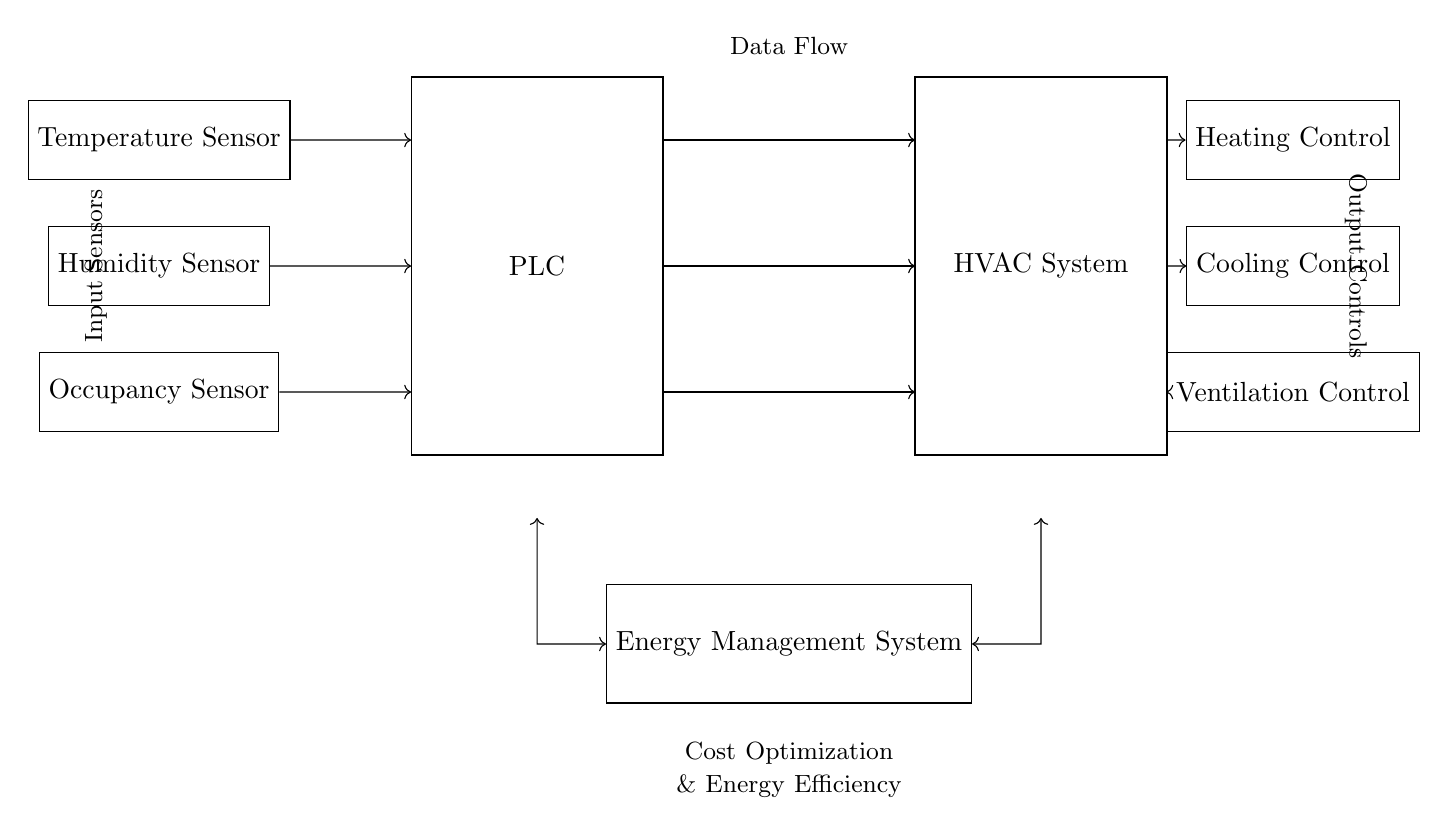What are the types of sensors in the circuit? The circuit features three types of sensors: temperature, humidity, and occupancy sensors. Each sensor is represented in the diagram, indicating their specific role in monitoring environmental conditions.
Answer: Temperature, humidity, occupancy What component manages the energy efficiency? The Energy Management System (EMS) is responsible for optimizing costs and energy efficiency in the circuit. It is represented by a rectangle labeled "Energy Management System."
Answer: Energy Management System How many output control components are there? There are three output control components: heating control, cooling control, and ventilation control. Each is clearly marked in the diagram, indicating their function in the HVAC system.
Answer: Three Which sensors send data to the PLC? The sensors that send data to the PLC are the temperature sensor, humidity sensor, and occupancy sensor. These sensors are connected by arrows pointing towards the PLC, indicating the data flow direction.
Answer: Temperature sensor, humidity sensor, occupancy sensor What is the main purpose of the PLC in this system? The PLC's main purpose is to process information from the input sensors and control the HVAC system based on that data, optimizing energy usage and comfort. This can be deduced by its central placement between the sensors and HVAC system.
Answer: Process data Which control component responds to heating needs? The Heating Control component is specifically responsible for addressing heating needs in the HVAC system, indicated by its distinct label in the diagram.
Answer: Heating Control 